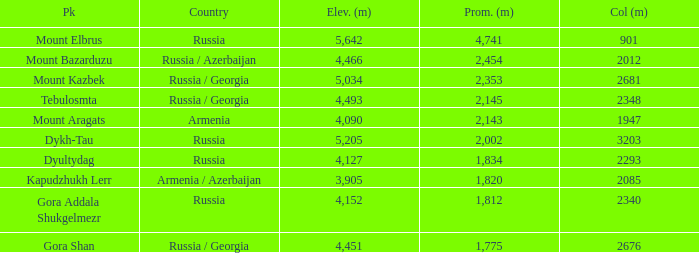What is the Elevation (m) of the Peak with a Prominence (m) larger than 2,143 and Col (m) of 2012? 4466.0. 